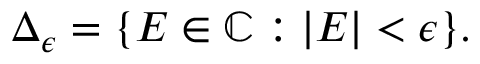<formula> <loc_0><loc_0><loc_500><loc_500>\begin{array} { r } { \Delta _ { \epsilon } = \{ E \in \mathbb { C } \colon | E | < \epsilon \} . } \end{array}</formula> 